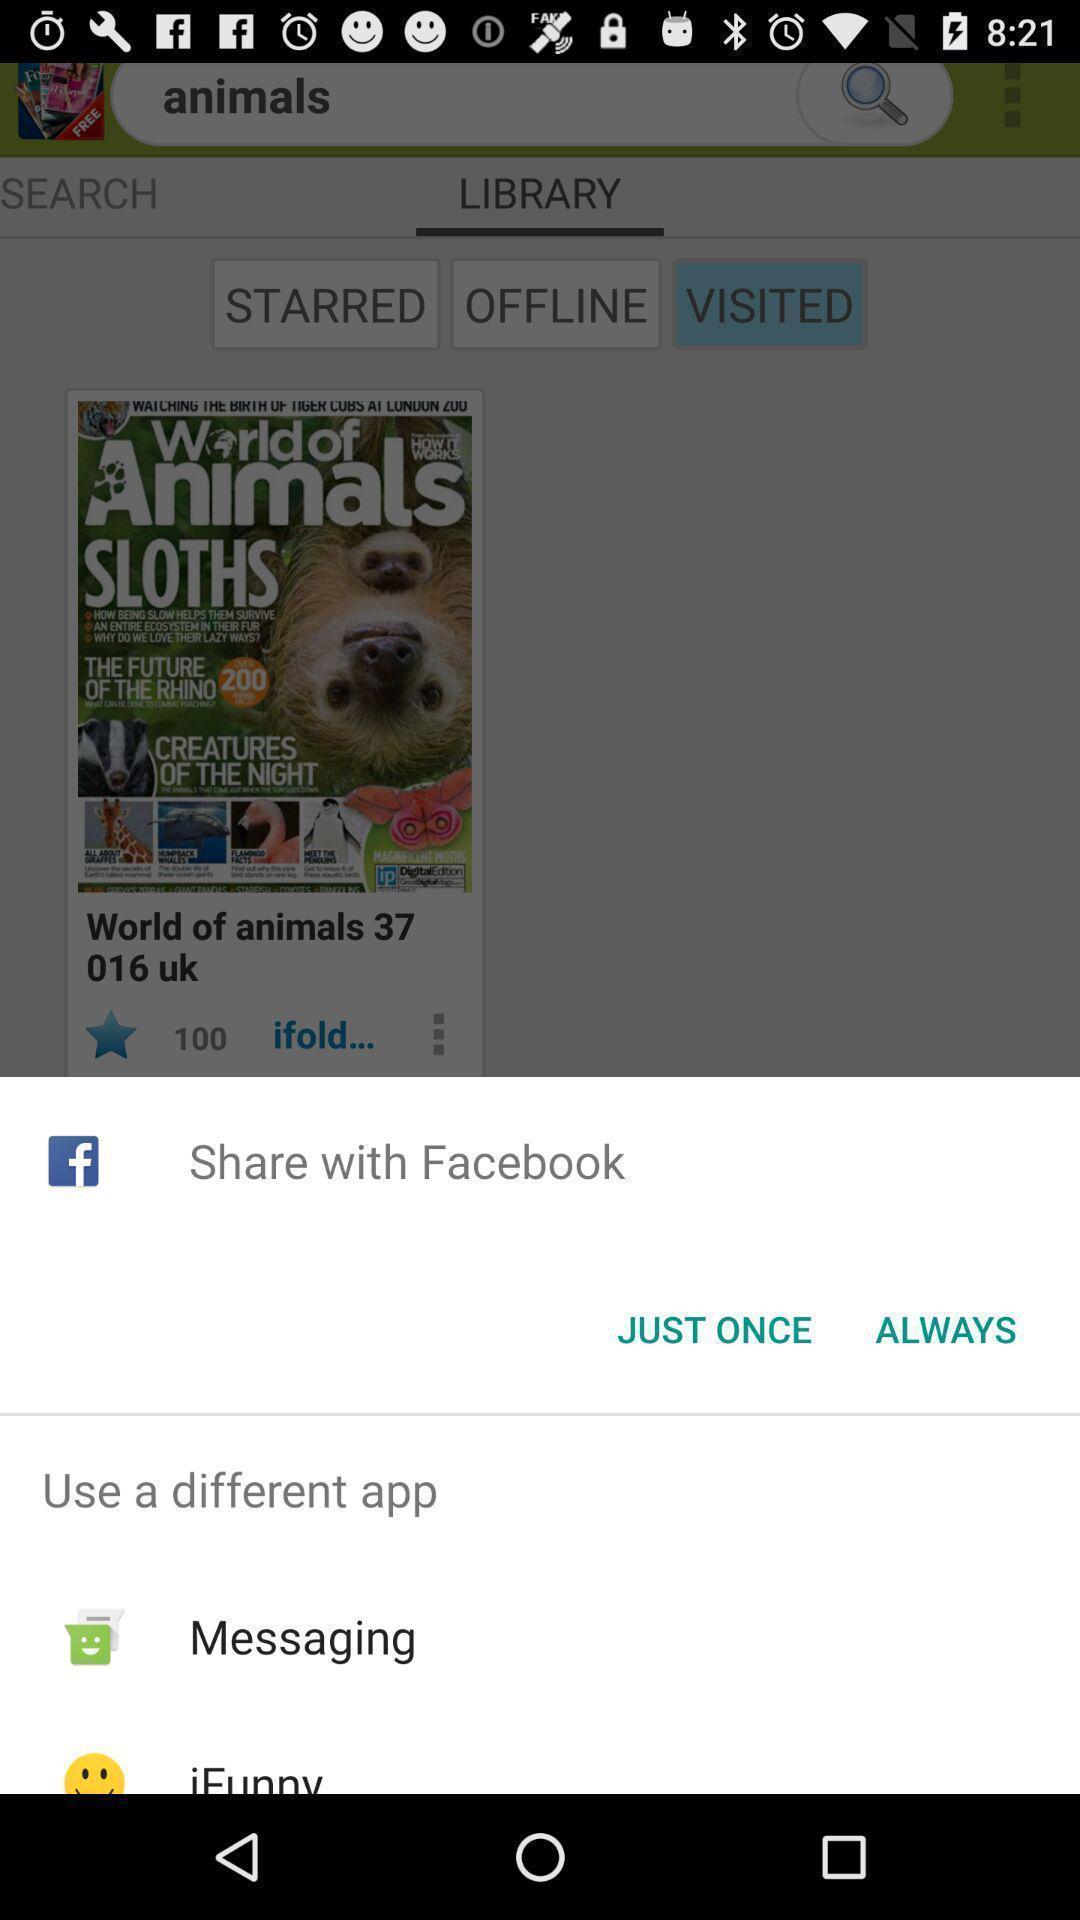Summarize the main components in this picture. Widget showing different sharing options. 